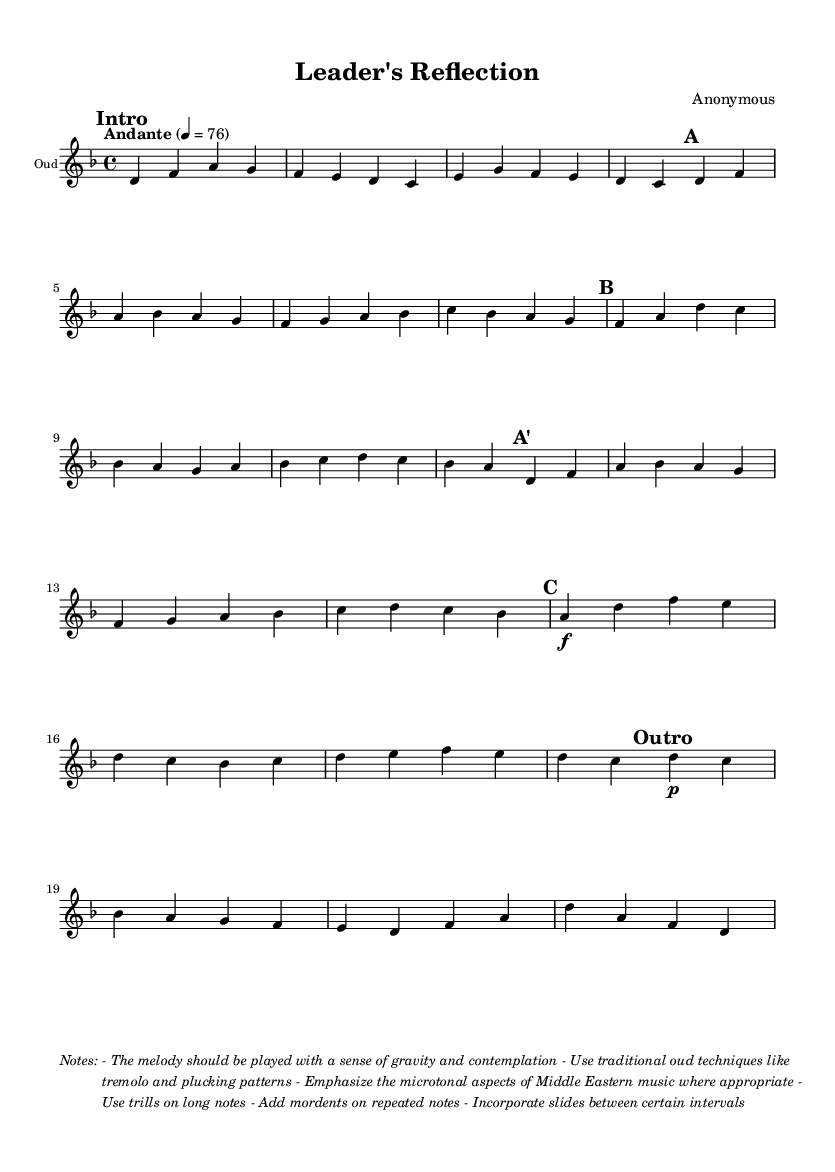What is the key signature of this music? The key signature is indicated at the beginning of the sheet music, showing two flats (B and E), which corresponds to D minor.
Answer: D minor What is the time signature of this music? The time signature is found at the beginning of the piece; it displays a 4 over 4, indicating four beats per measure with a quarter note getting one beat.
Answer: 4/4 What is the tempo marking for this piece? The tempo marking is noted at the start of the score, which specifies "Andante" with a metronome marking of 76 beats per minute.
Answer: Andante, 76 How many sections does the music have? By observing the structure of the piece, there are six clearly marked sections: Intro, A, B, A', C, and Outro.
Answer: 6 What traditional oud techniques are suggested for this piece? The notes section describes the use of traditional oud techniques, specifically mentioning tremolo and plucking patterns, along with other ornamentations.
Answer: Tremolo, plucking patterns Which section begins with the note A? The section labeled “A" starts with the note D, but the second section "B" also begins with the note F, which is the first note of that section.
Answer: B What microtonal aspects should be emphasized in this melody? The notes section suggests that the microtonal aspects of Middle Eastern music should be emphasized, suggesting a distinctive character to the melodic lines.
Answer: Microtonal aspects 